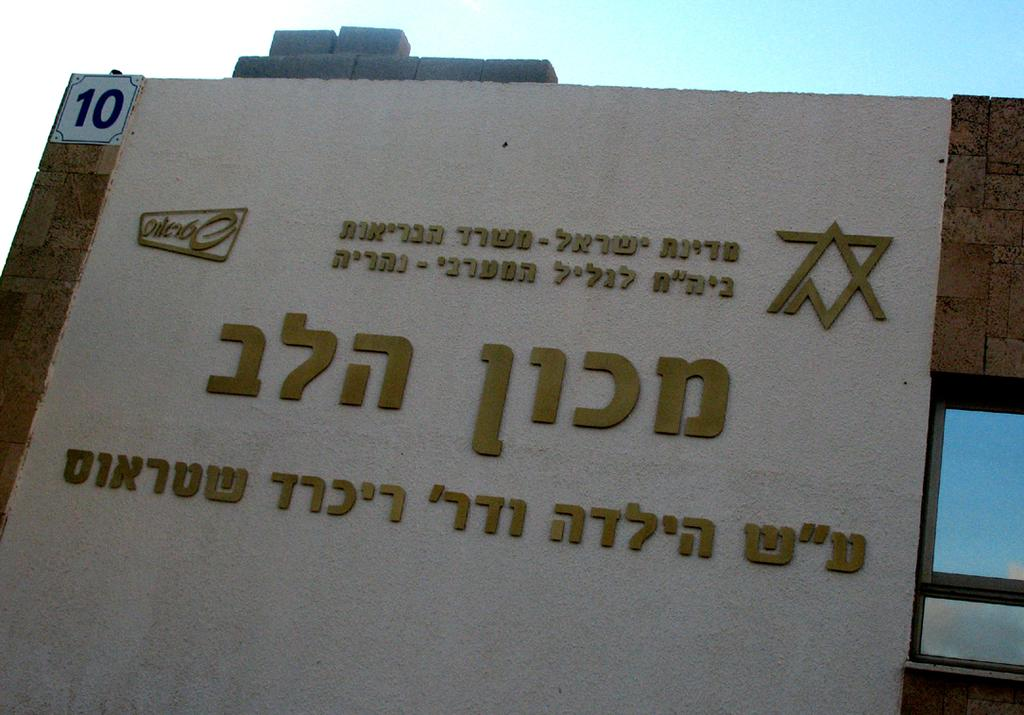What is the main object in the image with information on it? There is a board with information in the image. What color is the screen beside the board? The screen beside the board is blue. What can be seen in the background of the image? The sky is visible behind the board. How many fish are swimming in the sky in the image? There are no fish visible in the sky in the image. Is there a goat present in the image? There is no goat present in the image. 